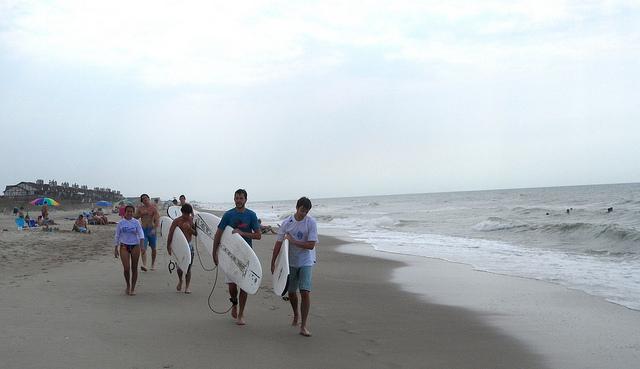What uniforms are the men wearing?
Keep it brief. Shorts. What color umbrella can be seen in the background?
Write a very short answer. Rainbow. How is the weather?
Keep it brief. Cloudy. How many surfers are walking on the sidewalk?
Quick response, please. 0. Are they wearing wetsuits?
Short answer required. No. Is the man's surfboard name brand?
Short answer required. No. Are there people swimming?
Be succinct. Yes. What are the men holding in hands?
Give a very brief answer. Surfboards. Is this a competition?
Concise answer only. No. What does sand feel like?
Short answer required. Wet. 